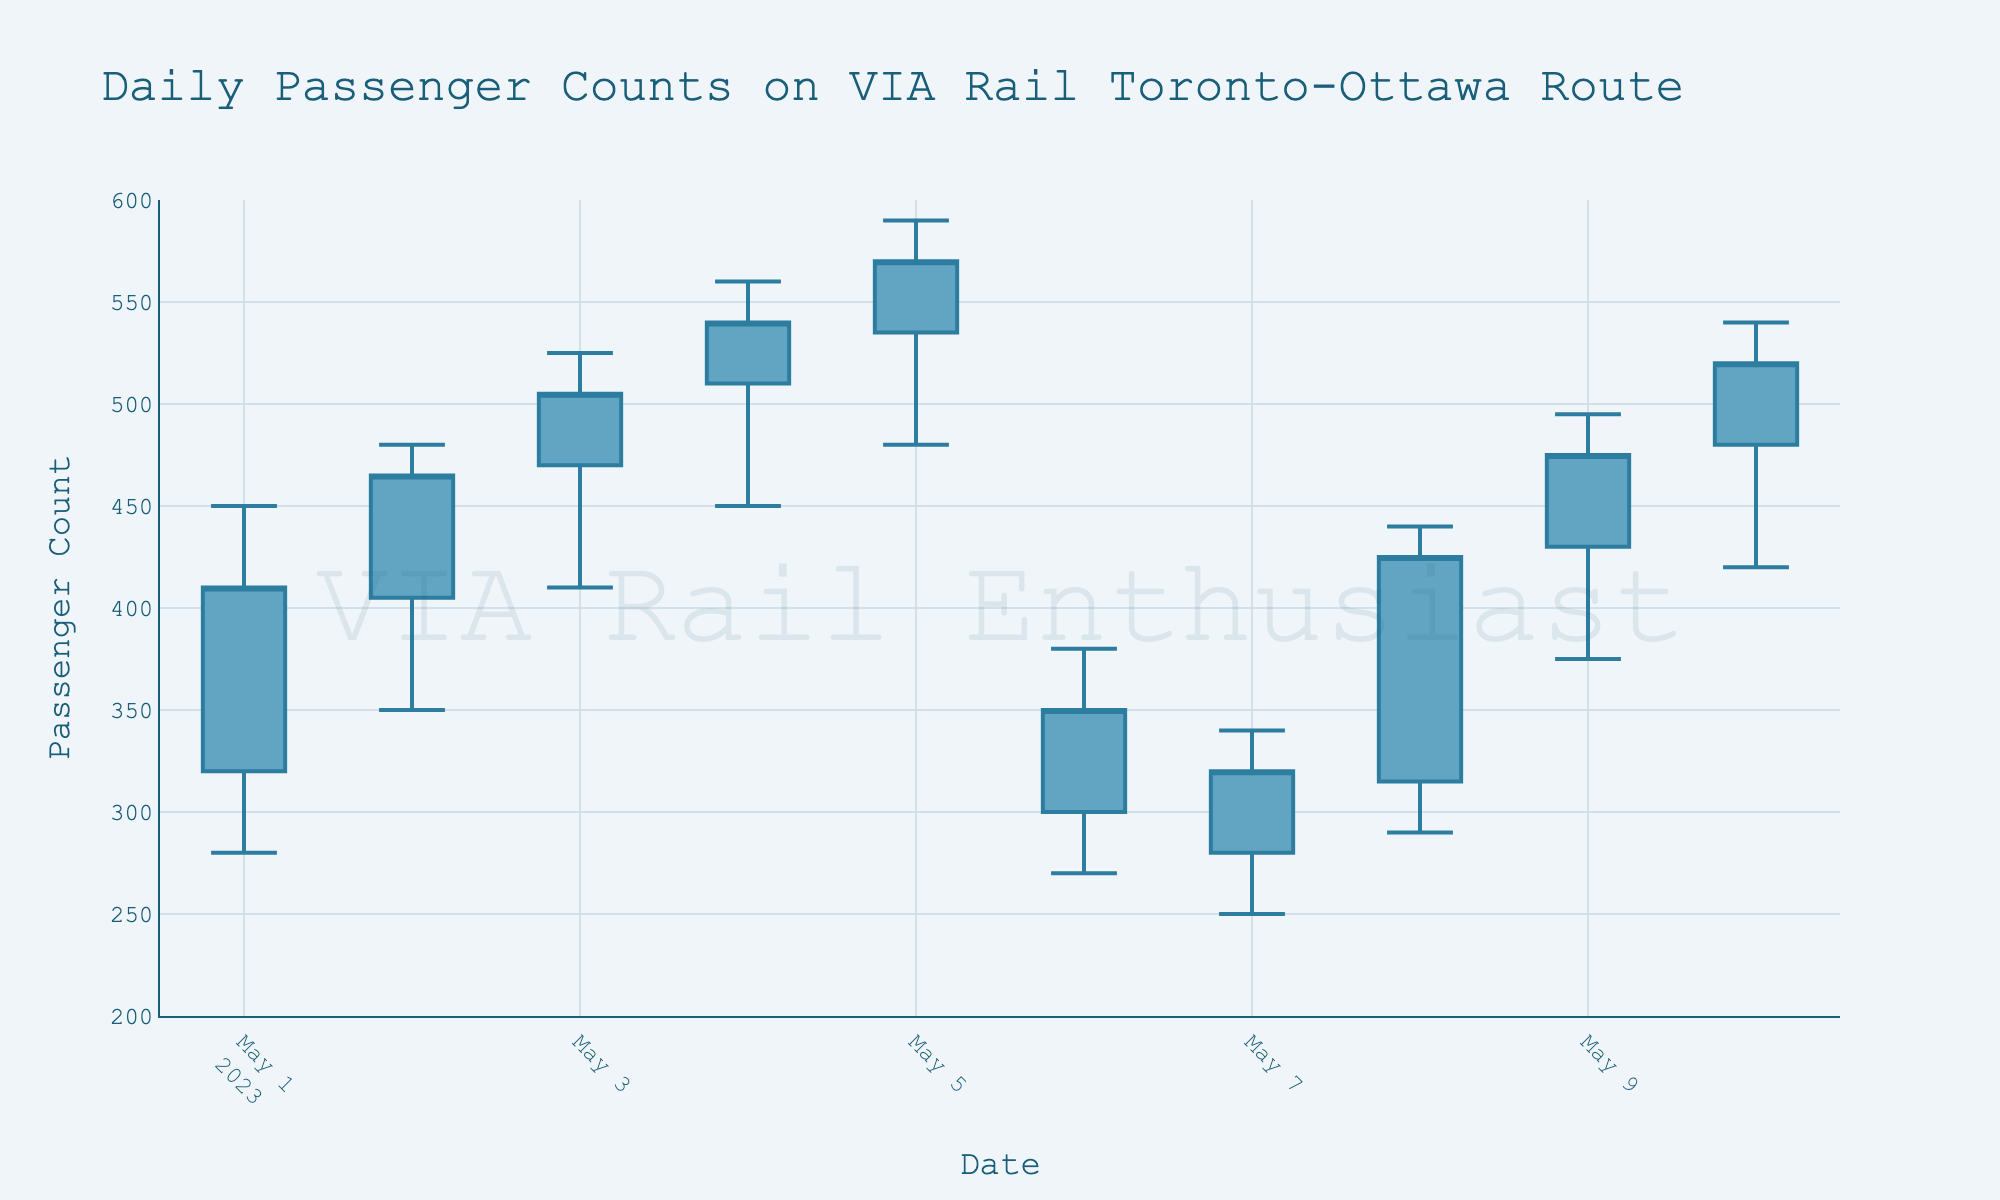What is the title of the chart? The title is usually displayed at the top of the chart and provides a summary of what the chart is about.
Answer: Daily Passenger Counts on VIA Rail Toronto-Ottawa Route What are the starting and ending dates in the chart? The dates are shown on the x-axis of the chart. By observing the first and the last date plot, we can determine the starting and ending dates.
Answer: 2023-05-01 to 2023-05-10 Which day showed the highest passenger count? The highest passenger count corresponds to the highest 'High' value in the chart. We can locate this value by identifying the tallest candlestick.
Answer: May 5, 2023, with 590 passengers On which day did the passenger count open and close at the same value? 'Open' and 'Close' values are shown for each candlestick. By locating a candlestick where these values are equal, we can determine the day.
Answer: No day has the same 'Open' and 'Close' values On which day was the difference between the 'High' and 'Low' values the greatest, and what was the difference? Calculate the difference ('High' - 'Low') for each day and find the maximum difference.
Answer: May 5, 2023, with a difference of 110 What is the average closing passenger count for the first week of May? Sum the closing values for May 1 to May 7, then divide by the number of days. Calculation: (410 + 465 + 505 + 540 + 570 + 350 + 320) / 7
Answer: 451.43 Which two consecutive days showed the most significant increase in the closing passenger count? For each pair of consecutive days, calculate the difference in 'Close' values and find the maximum increase.
Answer: May 7 to May 8, with an increase of 105 How many days had a 'Close' value higher than the 'Open' value? For each day, compare the 'Close' and 'Open' values. Count the number of days where 'Close' is higher than 'Open'.
Answer: 7 days What color represents an increasing trend in the candlestick chart? The chart uses different colors to indicate increasing and decreasing trends. The increasing trend color is typically used for candlesticks where 'Close' is higher than 'Open'.
Answer: Light blue (for increasing) On which date did the chart show the lowest 'Low' value, and what was the value? Identify the day with the lowest point on any candlestick and read the 'Low' value.
Answer: May 7, 2023, with 250 passengers 